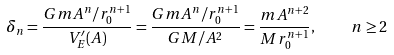<formula> <loc_0><loc_0><loc_500><loc_500>\delta _ { n } = { \frac { G m A ^ { n } / r _ { 0 } ^ { n + 1 } } { V _ { E } ^ { \prime } ( A ) } } = { \frac { G m A ^ { n } / r _ { 0 } ^ { n + 1 } } { G M / A ^ { 2 } } } = { \frac { m A ^ { n + 2 } } { M r _ { 0 } ^ { n + 1 } } } , \quad n \geq 2</formula> 